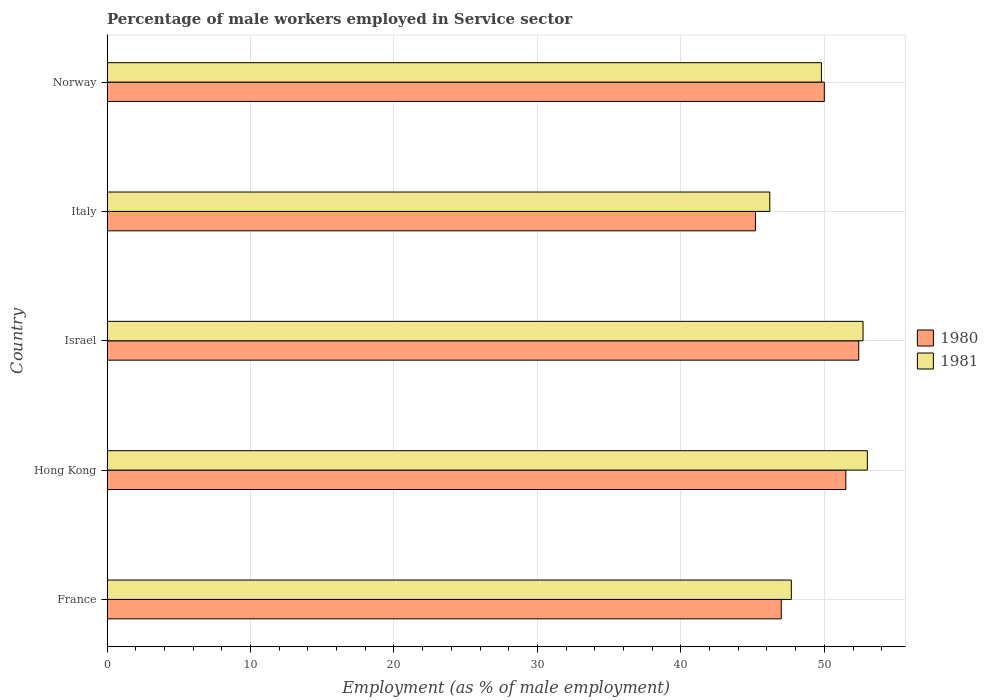How many different coloured bars are there?
Offer a terse response. 2. How many groups of bars are there?
Give a very brief answer. 5. Are the number of bars per tick equal to the number of legend labels?
Your answer should be compact. Yes. Are the number of bars on each tick of the Y-axis equal?
Provide a succinct answer. Yes. What is the label of the 4th group of bars from the top?
Ensure brevity in your answer.  Hong Kong. What is the percentage of male workers employed in Service sector in 1981 in Israel?
Your answer should be compact. 52.7. Across all countries, what is the maximum percentage of male workers employed in Service sector in 1980?
Your response must be concise. 52.4. Across all countries, what is the minimum percentage of male workers employed in Service sector in 1980?
Keep it short and to the point. 45.2. In which country was the percentage of male workers employed in Service sector in 1980 maximum?
Ensure brevity in your answer.  Israel. In which country was the percentage of male workers employed in Service sector in 1980 minimum?
Keep it short and to the point. Italy. What is the total percentage of male workers employed in Service sector in 1980 in the graph?
Your answer should be compact. 246.1. What is the difference between the percentage of male workers employed in Service sector in 1981 in Italy and that in Norway?
Give a very brief answer. -3.6. What is the difference between the percentage of male workers employed in Service sector in 1981 in Israel and the percentage of male workers employed in Service sector in 1980 in France?
Provide a short and direct response. 5.7. What is the average percentage of male workers employed in Service sector in 1980 per country?
Make the answer very short. 49.22. In how many countries, is the percentage of male workers employed in Service sector in 1981 greater than 34 %?
Keep it short and to the point. 5. What is the ratio of the percentage of male workers employed in Service sector in 1980 in France to that in Hong Kong?
Provide a short and direct response. 0.91. Is the percentage of male workers employed in Service sector in 1980 in France less than that in Israel?
Offer a terse response. Yes. What is the difference between the highest and the second highest percentage of male workers employed in Service sector in 1980?
Make the answer very short. 0.9. What is the difference between the highest and the lowest percentage of male workers employed in Service sector in 1981?
Provide a succinct answer. 6.8. In how many countries, is the percentage of male workers employed in Service sector in 1980 greater than the average percentage of male workers employed in Service sector in 1980 taken over all countries?
Offer a very short reply. 3. Is the sum of the percentage of male workers employed in Service sector in 1981 in Israel and Norway greater than the maximum percentage of male workers employed in Service sector in 1980 across all countries?
Provide a short and direct response. Yes. What does the 2nd bar from the bottom in France represents?
Offer a very short reply. 1981. Are all the bars in the graph horizontal?
Your answer should be very brief. Yes. How many countries are there in the graph?
Offer a terse response. 5. What is the difference between two consecutive major ticks on the X-axis?
Your response must be concise. 10. Does the graph contain any zero values?
Provide a succinct answer. No. Does the graph contain grids?
Give a very brief answer. Yes. Where does the legend appear in the graph?
Ensure brevity in your answer.  Center right. How many legend labels are there?
Give a very brief answer. 2. What is the title of the graph?
Provide a short and direct response. Percentage of male workers employed in Service sector. What is the label or title of the X-axis?
Provide a succinct answer. Employment (as % of male employment). What is the label or title of the Y-axis?
Provide a short and direct response. Country. What is the Employment (as % of male employment) in 1980 in France?
Your response must be concise. 47. What is the Employment (as % of male employment) in 1981 in France?
Your response must be concise. 47.7. What is the Employment (as % of male employment) in 1980 in Hong Kong?
Your response must be concise. 51.5. What is the Employment (as % of male employment) of 1980 in Israel?
Offer a terse response. 52.4. What is the Employment (as % of male employment) of 1981 in Israel?
Ensure brevity in your answer.  52.7. What is the Employment (as % of male employment) in 1980 in Italy?
Ensure brevity in your answer.  45.2. What is the Employment (as % of male employment) of 1981 in Italy?
Your response must be concise. 46.2. What is the Employment (as % of male employment) of 1980 in Norway?
Keep it short and to the point. 50. What is the Employment (as % of male employment) of 1981 in Norway?
Offer a very short reply. 49.8. Across all countries, what is the maximum Employment (as % of male employment) in 1980?
Offer a very short reply. 52.4. Across all countries, what is the maximum Employment (as % of male employment) in 1981?
Provide a succinct answer. 53. Across all countries, what is the minimum Employment (as % of male employment) of 1980?
Provide a succinct answer. 45.2. Across all countries, what is the minimum Employment (as % of male employment) of 1981?
Make the answer very short. 46.2. What is the total Employment (as % of male employment) in 1980 in the graph?
Offer a very short reply. 246.1. What is the total Employment (as % of male employment) of 1981 in the graph?
Offer a very short reply. 249.4. What is the difference between the Employment (as % of male employment) in 1980 in France and that in Hong Kong?
Ensure brevity in your answer.  -4.5. What is the difference between the Employment (as % of male employment) in 1980 in France and that in Israel?
Your answer should be very brief. -5.4. What is the difference between the Employment (as % of male employment) in 1981 in France and that in Israel?
Make the answer very short. -5. What is the difference between the Employment (as % of male employment) in 1980 in France and that in Italy?
Provide a short and direct response. 1.8. What is the difference between the Employment (as % of male employment) of 1980 in Hong Kong and that in Israel?
Your answer should be very brief. -0.9. What is the difference between the Employment (as % of male employment) of 1981 in Hong Kong and that in Israel?
Ensure brevity in your answer.  0.3. What is the difference between the Employment (as % of male employment) in 1981 in Hong Kong and that in Italy?
Ensure brevity in your answer.  6.8. What is the difference between the Employment (as % of male employment) in 1981 in Hong Kong and that in Norway?
Ensure brevity in your answer.  3.2. What is the difference between the Employment (as % of male employment) in 1981 in Israel and that in Italy?
Offer a very short reply. 6.5. What is the difference between the Employment (as % of male employment) of 1980 in Israel and that in Norway?
Offer a very short reply. 2.4. What is the difference between the Employment (as % of male employment) of 1980 in Italy and that in Norway?
Your answer should be very brief. -4.8. What is the difference between the Employment (as % of male employment) of 1981 in Italy and that in Norway?
Keep it short and to the point. -3.6. What is the difference between the Employment (as % of male employment) in 1980 in France and the Employment (as % of male employment) in 1981 in Italy?
Keep it short and to the point. 0.8. What is the difference between the Employment (as % of male employment) of 1980 in France and the Employment (as % of male employment) of 1981 in Norway?
Your response must be concise. -2.8. What is the difference between the Employment (as % of male employment) in 1980 in Hong Kong and the Employment (as % of male employment) in 1981 in Italy?
Make the answer very short. 5.3. What is the difference between the Employment (as % of male employment) of 1980 in Hong Kong and the Employment (as % of male employment) of 1981 in Norway?
Your answer should be compact. 1.7. What is the difference between the Employment (as % of male employment) of 1980 in Israel and the Employment (as % of male employment) of 1981 in Norway?
Offer a terse response. 2.6. What is the difference between the Employment (as % of male employment) in 1980 in Italy and the Employment (as % of male employment) in 1981 in Norway?
Offer a very short reply. -4.6. What is the average Employment (as % of male employment) in 1980 per country?
Give a very brief answer. 49.22. What is the average Employment (as % of male employment) in 1981 per country?
Keep it short and to the point. 49.88. What is the difference between the Employment (as % of male employment) in 1980 and Employment (as % of male employment) in 1981 in Hong Kong?
Provide a succinct answer. -1.5. What is the difference between the Employment (as % of male employment) in 1980 and Employment (as % of male employment) in 1981 in Israel?
Provide a succinct answer. -0.3. What is the difference between the Employment (as % of male employment) in 1980 and Employment (as % of male employment) in 1981 in Italy?
Offer a terse response. -1. What is the difference between the Employment (as % of male employment) in 1980 and Employment (as % of male employment) in 1981 in Norway?
Keep it short and to the point. 0.2. What is the ratio of the Employment (as % of male employment) of 1980 in France to that in Hong Kong?
Provide a succinct answer. 0.91. What is the ratio of the Employment (as % of male employment) of 1981 in France to that in Hong Kong?
Ensure brevity in your answer.  0.9. What is the ratio of the Employment (as % of male employment) of 1980 in France to that in Israel?
Offer a very short reply. 0.9. What is the ratio of the Employment (as % of male employment) in 1981 in France to that in Israel?
Keep it short and to the point. 0.91. What is the ratio of the Employment (as % of male employment) of 1980 in France to that in Italy?
Offer a terse response. 1.04. What is the ratio of the Employment (as % of male employment) of 1981 in France to that in Italy?
Provide a succinct answer. 1.03. What is the ratio of the Employment (as % of male employment) in 1981 in France to that in Norway?
Offer a terse response. 0.96. What is the ratio of the Employment (as % of male employment) of 1980 in Hong Kong to that in Israel?
Make the answer very short. 0.98. What is the ratio of the Employment (as % of male employment) in 1980 in Hong Kong to that in Italy?
Keep it short and to the point. 1.14. What is the ratio of the Employment (as % of male employment) of 1981 in Hong Kong to that in Italy?
Your response must be concise. 1.15. What is the ratio of the Employment (as % of male employment) in 1981 in Hong Kong to that in Norway?
Offer a very short reply. 1.06. What is the ratio of the Employment (as % of male employment) of 1980 in Israel to that in Italy?
Give a very brief answer. 1.16. What is the ratio of the Employment (as % of male employment) of 1981 in Israel to that in Italy?
Provide a short and direct response. 1.14. What is the ratio of the Employment (as % of male employment) in 1980 in Israel to that in Norway?
Ensure brevity in your answer.  1.05. What is the ratio of the Employment (as % of male employment) of 1981 in Israel to that in Norway?
Provide a succinct answer. 1.06. What is the ratio of the Employment (as % of male employment) in 1980 in Italy to that in Norway?
Your answer should be compact. 0.9. What is the ratio of the Employment (as % of male employment) in 1981 in Italy to that in Norway?
Your answer should be compact. 0.93. What is the difference between the highest and the second highest Employment (as % of male employment) of 1980?
Your answer should be compact. 0.9. What is the difference between the highest and the second highest Employment (as % of male employment) in 1981?
Keep it short and to the point. 0.3. 